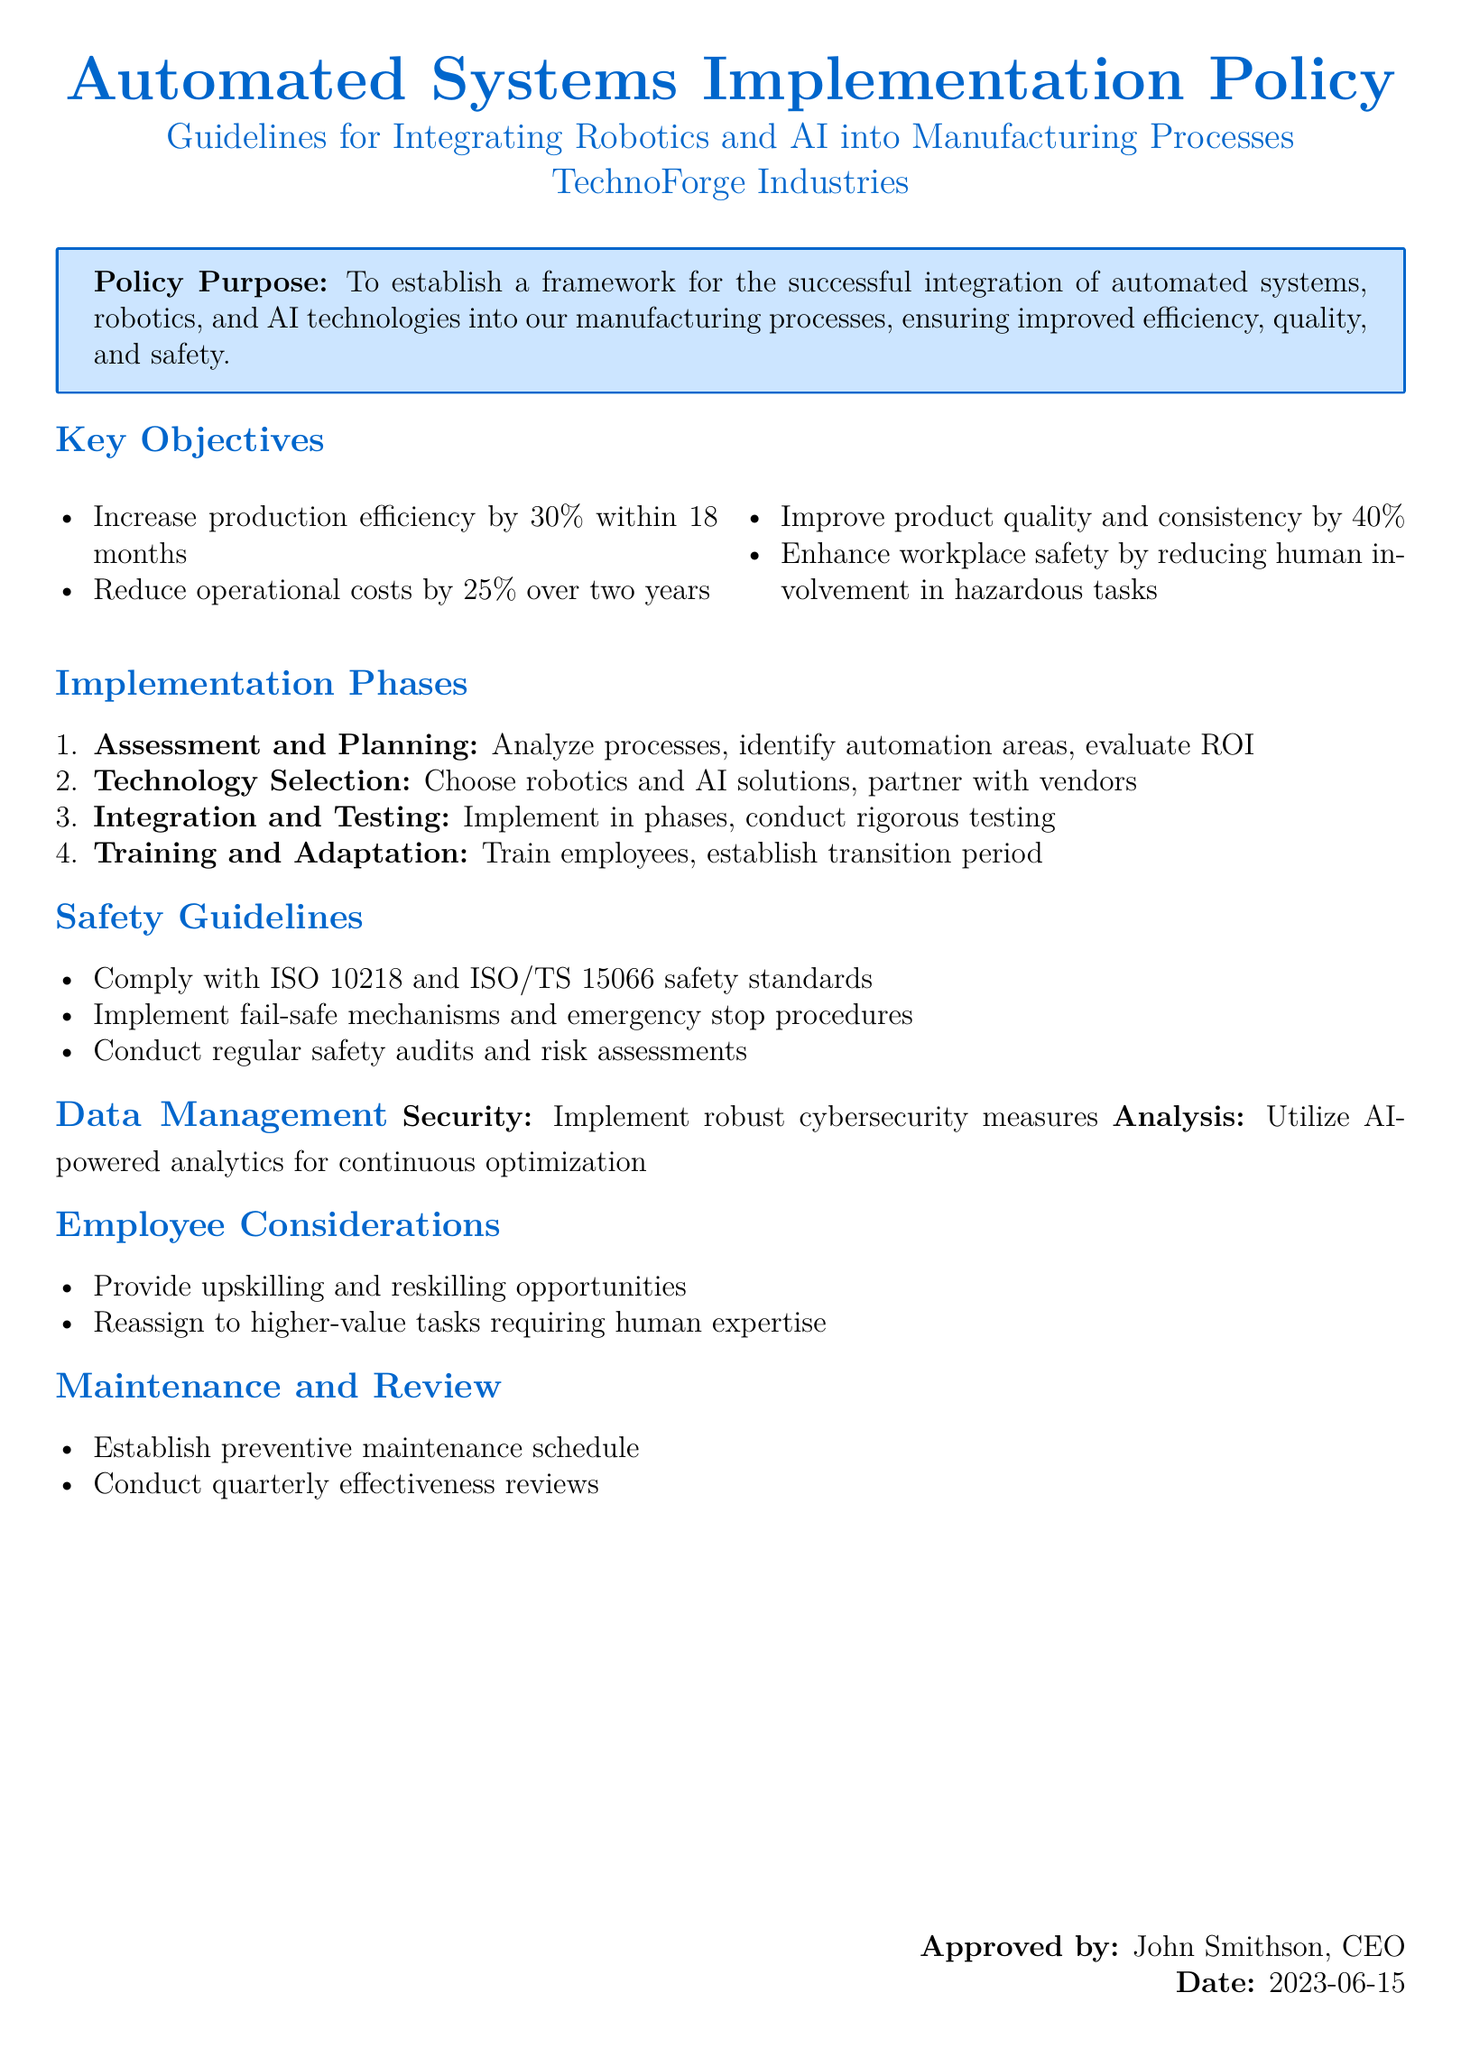What is the policy purpose? The policy purpose is to establish a framework for the successful integration of automated systems, robotics, and AI technologies into manufacturing processes.
Answer: To establish a framework for the successful integration of automated systems, robotics, and AI technologies into our manufacturing processes What is the expected increase in production efficiency? The document specifies a target for increasing production efficiency, which is a percentage.
Answer: 30% How long is the timeline for reducing operational costs? The document specifies a timeframe over which operational costs are intended to be reduced.
Answer: Two years What safety standard must be complied with according to the guidelines? The document mentions specific safety standards that must be followed.
Answer: ISO 10218 What is the first phase of implementation? The stages of implementation are outlined in the document and the initial phase is explicitly stated.
Answer: Assessment and Planning How often should effectiveness reviews be conducted? The document specifies a frequency for reviews that assess the effectiveness of implemented systems.
Answer: Quarterly What type of opportunities should be provided for employees? The document highlights types of opportunities related to employee development within the company.
Answer: Upskilling and reskilling What is the role of AI in data management? The document describes how AI is used in the context of ongoing improvement and data analysis.
Answer: AI-powered analytics for continuous optimization 